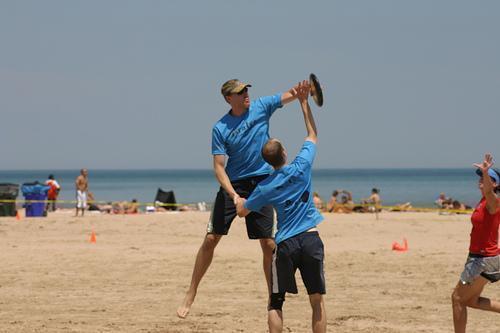How many people are wearing blue shirts?
Give a very brief answer. 2. How many people reaching for the frisbee are wearing red?
Give a very brief answer. 1. 